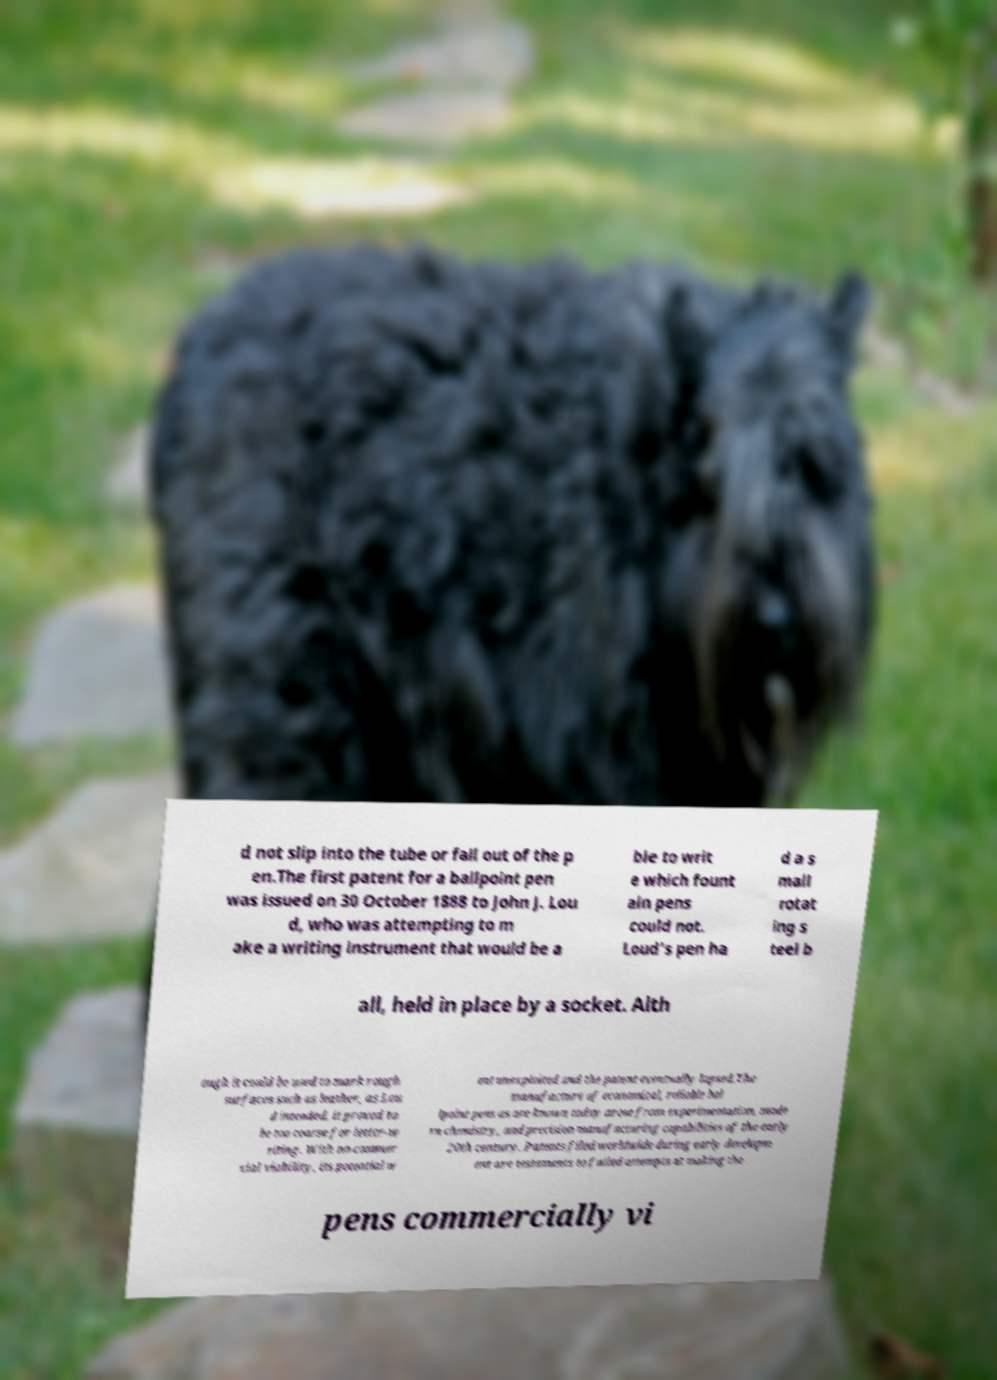For documentation purposes, I need the text within this image transcribed. Could you provide that? d not slip into the tube or fall out of the p en.The first patent for a ballpoint pen was issued on 30 October 1888 to John J. Lou d, who was attempting to m ake a writing instrument that would be a ble to writ e which fount ain pens could not. Loud's pen ha d a s mall rotat ing s teel b all, held in place by a socket. Alth ough it could be used to mark rough surfaces such as leather, as Lou d intended, it proved to be too coarse for letter-w riting. With no commer cial viability, its potential w ent unexploited and the patent eventually lapsed.The manufacture of economical, reliable bal lpoint pens as are known today arose from experimentation, mode rn chemistry, and precision manufacturing capabilities of the early 20th century. Patents filed worldwide during early developm ent are testaments to failed attempts at making the pens commercially vi 